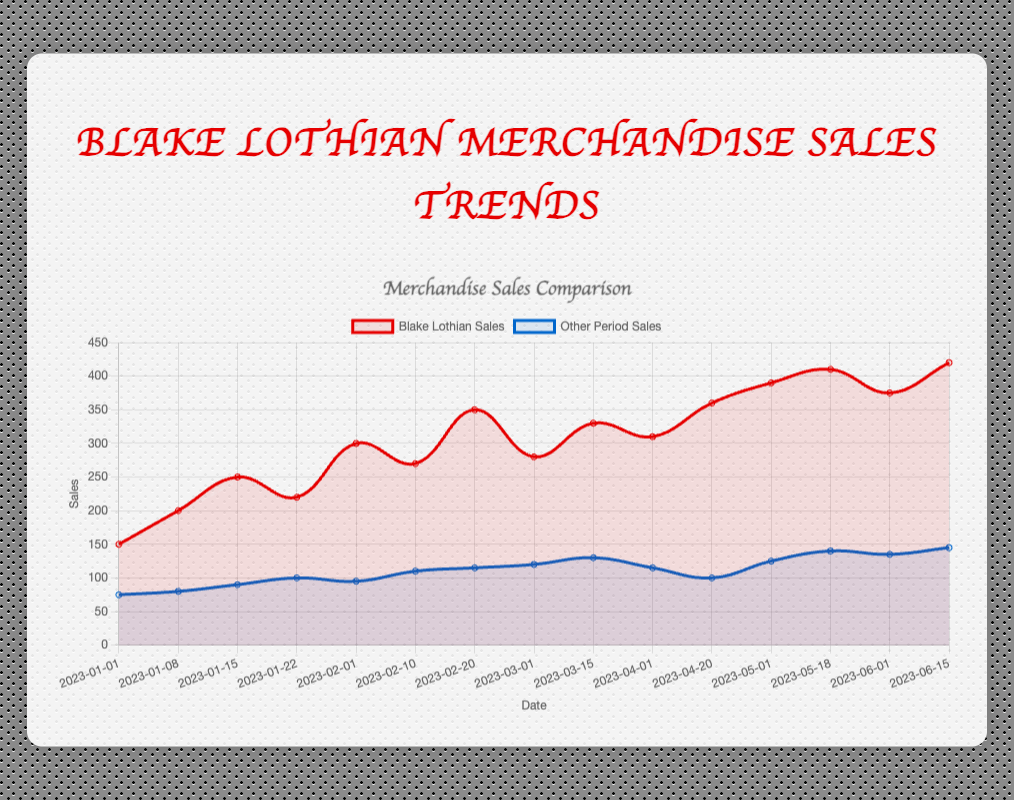What is the difference in sales between Blake Lothian and other periods on 2023-06-15? On 2023-06-15, Blake Lothian's sales are 420, and other period sales are 145. The difference is 420 - 145.
Answer: 275 During which date did Blake Lothian's sales first exceed 300 units? The dates and sales are compared sequentially. The first occurrence of Blake Lothian's sales exceeding 300 units is on 2023-02-01 with 300 sales.
Answer: 2023-02-01 What is the average merchandise sales for Blake Lothian from 2023-01-01 to 2023-02-20? Sum the sales from 2023-01-01 to 2023-02-20: 150 + 200 + 250 + 220 + 300 + 270 + 350 = 1740. Divide by the number of data points (7): 1740 / 7.
Answer: 248.57 How do the trends in sales for Blake Lothian compare to other periods overall from the start to end? Visually, Blake Lothian's sales show a general increasing trend with fluctuations but always staying above the sales from other periods, which also show a moderate increasing trend but at a lower range.
Answer: Blake Lothian shows a stronger increasing trend By how much did Blake Lothian's sales increase from 2023-04-01 to 2023-05-01? Sales on 2023-04-01 were 310, and on 2023-05-01 were 390. The increase is 390 - 310.
Answer: 80 What color represents the trend line for Blake Lothian's sales? The visual attribute representing Blake Lothian's sales trend line in the plot is red.
Answer: Red Which date shows the smallest gap between Blake Lothian's sales and other periods' sales? Visually inspect the graph or calculate the differences. The smallest gap is on 2023-01-01, where the sales difference is 150 - 75 = 75.
Answer: 2023-01-01 What's the maximum merchandise sales for other periods within the timeframe? Inspect the chart or the data values, and the highest sales value for other periods is 145 on 2023-06-15.
Answer: 145 On which date did Blake Lothian's sales experience the highest peak within the given timeframe? Inspect the chart where Blake Lothian's sales reach the highest value, which is on 2023-06-15 with 420 units.
Answer: 2023-06-15 What is the cumulative sales for Blake Lothian and other periods combined on 2023-03-15? Blake Lothian's sales on 2023-03-15 are 330, and other periods are 130. The combined sales are 330 + 130.
Answer: 460 